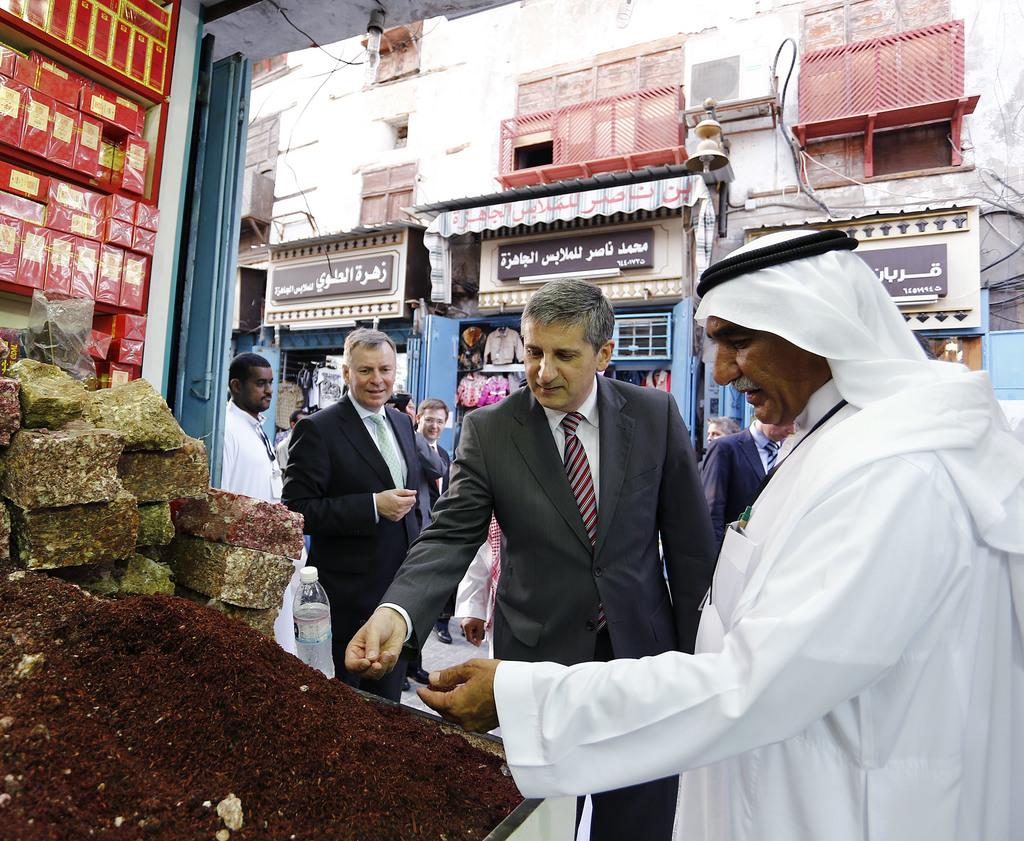What is happening in the image? There are persons standing in the image. What can be seen on the ground near the persons? There is a brown-colored powder in the image. What is blocking the view of the persons in the image? There are other objects in front of the persons. What can be seen in the distance behind the persons? There are stores visible in the background of the image. What is the size of the hole in the image? There is no hole present in the image. 